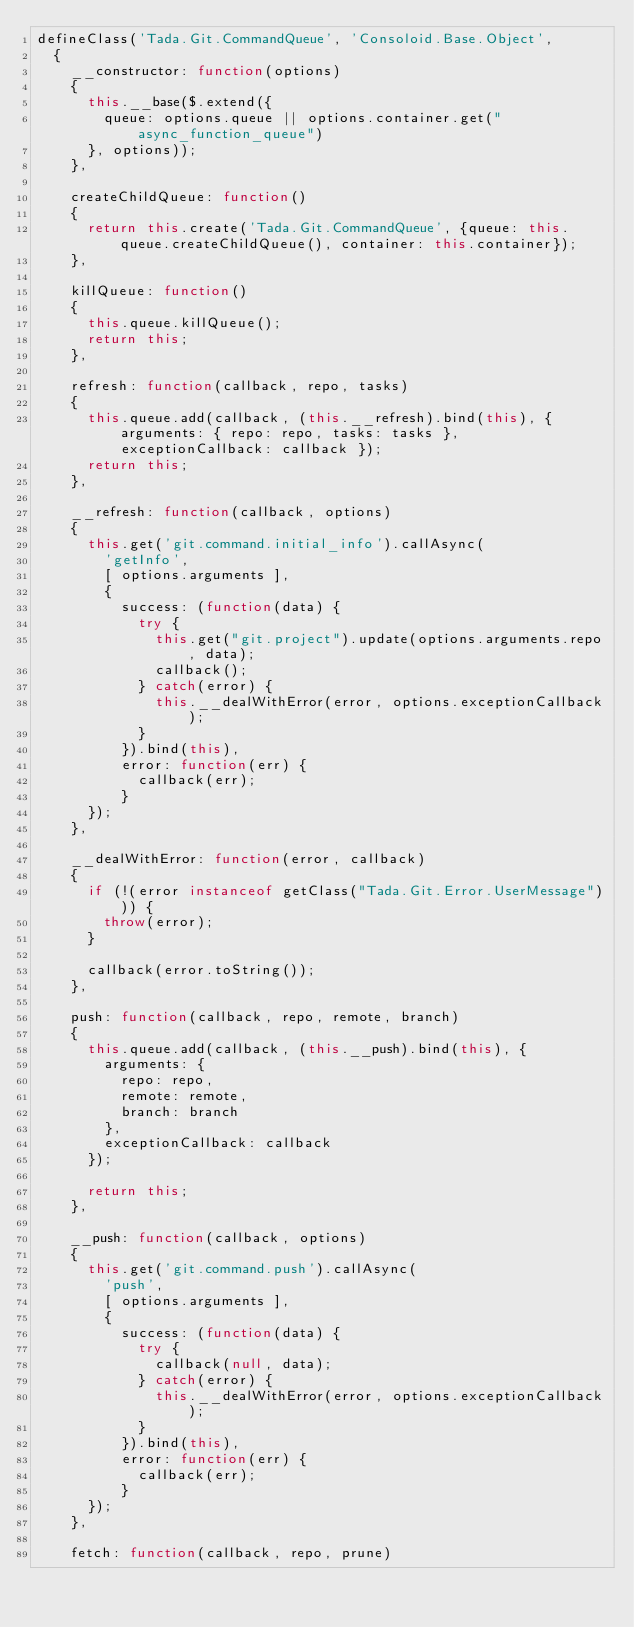Convert code to text. <code><loc_0><loc_0><loc_500><loc_500><_JavaScript_>defineClass('Tada.Git.CommandQueue', 'Consoloid.Base.Object',
  {
    __constructor: function(options)
    {
      this.__base($.extend({
        queue: options.queue || options.container.get("async_function_queue")
      }, options));
    },

    createChildQueue: function()
    {
      return this.create('Tada.Git.CommandQueue', {queue: this.queue.createChildQueue(), container: this.container});
    },

    killQueue: function()
    {
      this.queue.killQueue();
      return this;
    },

    refresh: function(callback, repo, tasks)
    {
      this.queue.add(callback, (this.__refresh).bind(this), { arguments: { repo: repo, tasks: tasks }, exceptionCallback: callback });
      return this;
    },

    __refresh: function(callback, options)
    {
      this.get('git.command.initial_info').callAsync(
        'getInfo',
        [ options.arguments ],
        {
          success: (function(data) {
            try {
              this.get("git.project").update(options.arguments.repo, data);
              callback();
            } catch(error) {
              this.__dealWithError(error, options.exceptionCallback);
            }
          }).bind(this),
          error: function(err) {
            callback(err);
          }
      });
    },

    __dealWithError: function(error, callback)
    {
      if (!(error instanceof getClass("Tada.Git.Error.UserMessage"))) {
        throw(error);
      }

      callback(error.toString());
    },

    push: function(callback, repo, remote, branch)
    {
      this.queue.add(callback, (this.__push).bind(this), {
        arguments: {
          repo: repo,
          remote: remote,
          branch: branch
        },
        exceptionCallback: callback
      });

      return this;
    },

    __push: function(callback, options)
    {
      this.get('git.command.push').callAsync(
        'push',
        [ options.arguments ],
        {
          success: (function(data) {
            try {
              callback(null, data);
            } catch(error) {
              this.__dealWithError(error, options.exceptionCallback);
            }
          }).bind(this),
          error: function(err) {
            callback(err);
          }
      });
    },

    fetch: function(callback, repo, prune)</code> 